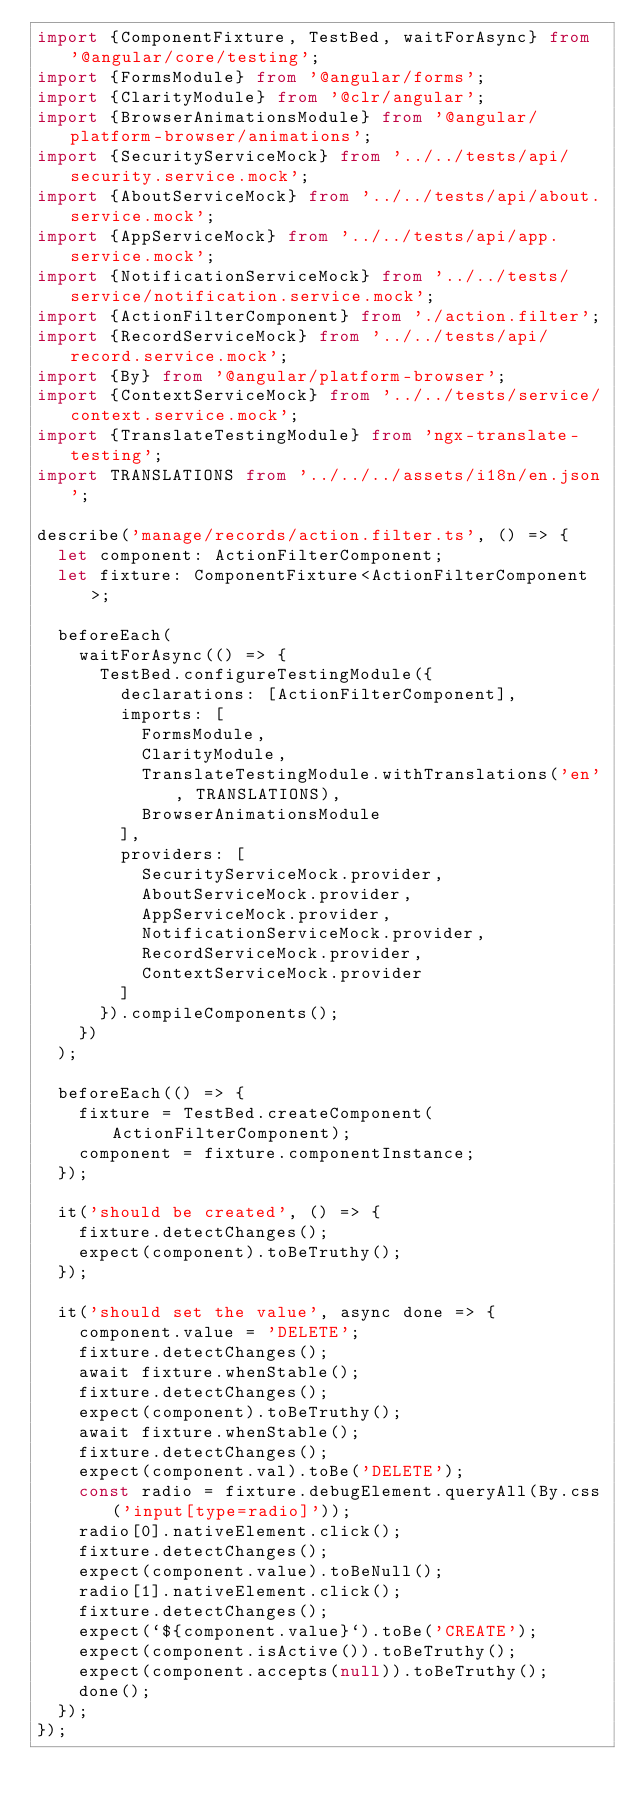Convert code to text. <code><loc_0><loc_0><loc_500><loc_500><_TypeScript_>import {ComponentFixture, TestBed, waitForAsync} from '@angular/core/testing';
import {FormsModule} from '@angular/forms';
import {ClarityModule} from '@clr/angular';
import {BrowserAnimationsModule} from '@angular/platform-browser/animations';
import {SecurityServiceMock} from '../../tests/api/security.service.mock';
import {AboutServiceMock} from '../../tests/api/about.service.mock';
import {AppServiceMock} from '../../tests/api/app.service.mock';
import {NotificationServiceMock} from '../../tests/service/notification.service.mock';
import {ActionFilterComponent} from './action.filter';
import {RecordServiceMock} from '../../tests/api/record.service.mock';
import {By} from '@angular/platform-browser';
import {ContextServiceMock} from '../../tests/service/context.service.mock';
import {TranslateTestingModule} from 'ngx-translate-testing';
import TRANSLATIONS from '../../../assets/i18n/en.json';

describe('manage/records/action.filter.ts', () => {
  let component: ActionFilterComponent;
  let fixture: ComponentFixture<ActionFilterComponent>;

  beforeEach(
    waitForAsync(() => {
      TestBed.configureTestingModule({
        declarations: [ActionFilterComponent],
        imports: [
          FormsModule,
          ClarityModule,
          TranslateTestingModule.withTranslations('en', TRANSLATIONS),
          BrowserAnimationsModule
        ],
        providers: [
          SecurityServiceMock.provider,
          AboutServiceMock.provider,
          AppServiceMock.provider,
          NotificationServiceMock.provider,
          RecordServiceMock.provider,
          ContextServiceMock.provider
        ]
      }).compileComponents();
    })
  );

  beforeEach(() => {
    fixture = TestBed.createComponent(ActionFilterComponent);
    component = fixture.componentInstance;
  });

  it('should be created', () => {
    fixture.detectChanges();
    expect(component).toBeTruthy();
  });

  it('should set the value', async done => {
    component.value = 'DELETE';
    fixture.detectChanges();
    await fixture.whenStable();
    fixture.detectChanges();
    expect(component).toBeTruthy();
    await fixture.whenStable();
    fixture.detectChanges();
    expect(component.val).toBe('DELETE');
    const radio = fixture.debugElement.queryAll(By.css('input[type=radio]'));
    radio[0].nativeElement.click();
    fixture.detectChanges();
    expect(component.value).toBeNull();
    radio[1].nativeElement.click();
    fixture.detectChanges();
    expect(`${component.value}`).toBe('CREATE');
    expect(component.isActive()).toBeTruthy();
    expect(component.accepts(null)).toBeTruthy();
    done();
  });
});
</code> 